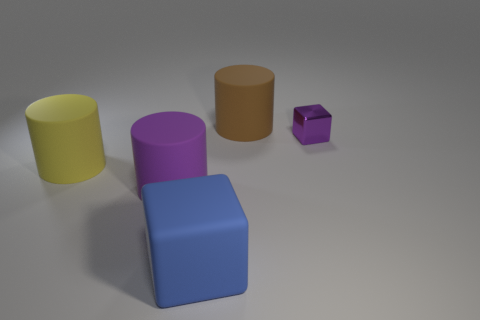Add 3 big purple cylinders. How many objects exist? 8 Subtract all cubes. How many objects are left? 3 Subtract all yellow cylinders. Subtract all large yellow things. How many objects are left? 3 Add 5 large yellow matte cylinders. How many large yellow matte cylinders are left? 6 Add 2 tiny purple metallic things. How many tiny purple metallic things exist? 3 Subtract 0 red spheres. How many objects are left? 5 